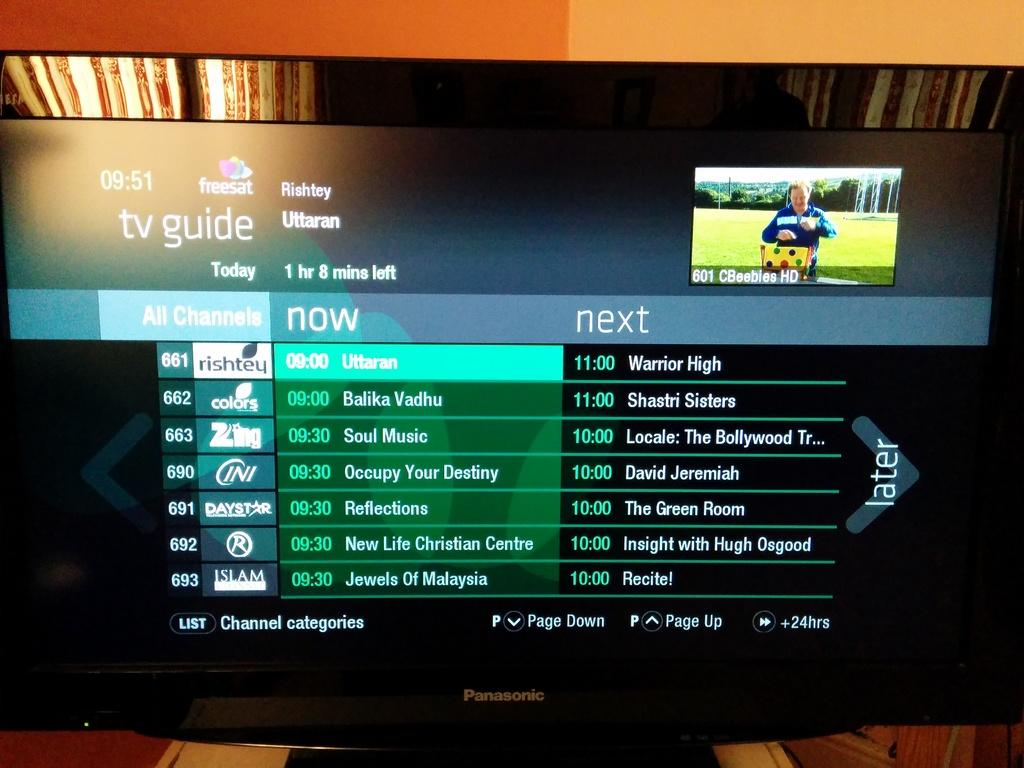<image>
Create a compact narrative representing the image presented. A Panasonic TV that is tuned in to the TV Guide channel. 